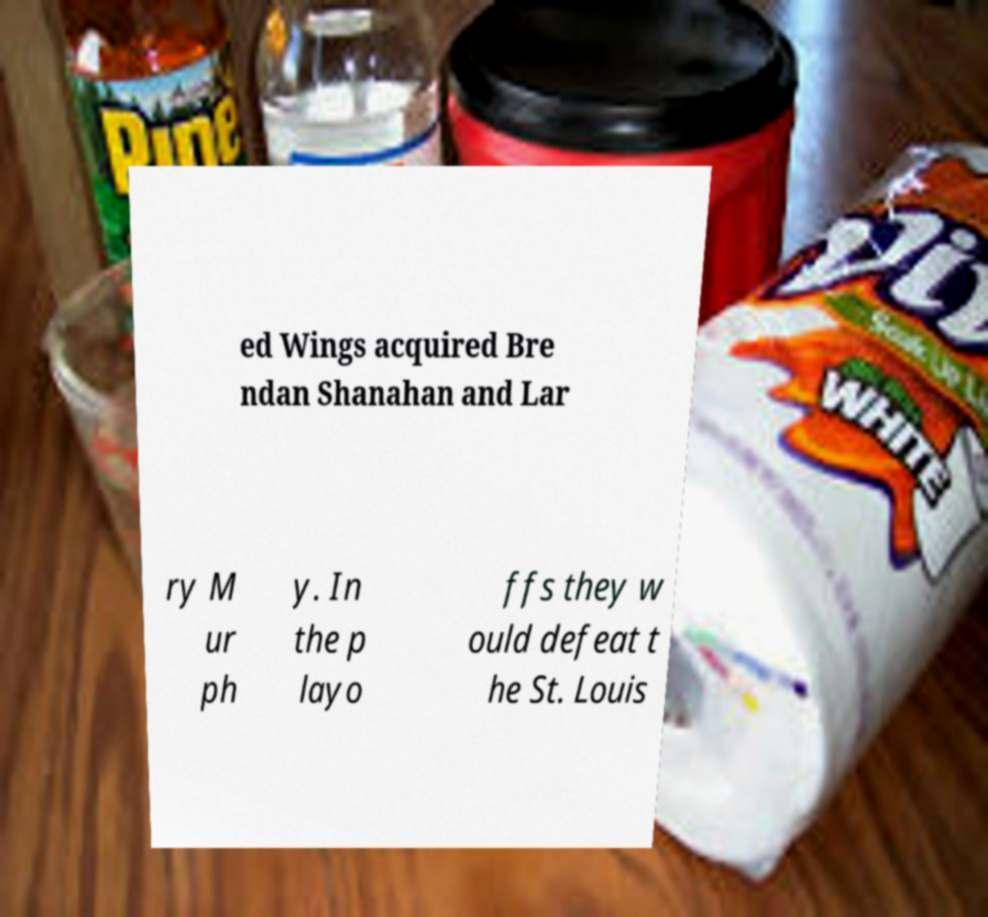Could you assist in decoding the text presented in this image and type it out clearly? ed Wings acquired Bre ndan Shanahan and Lar ry M ur ph y. In the p layo ffs they w ould defeat t he St. Louis 